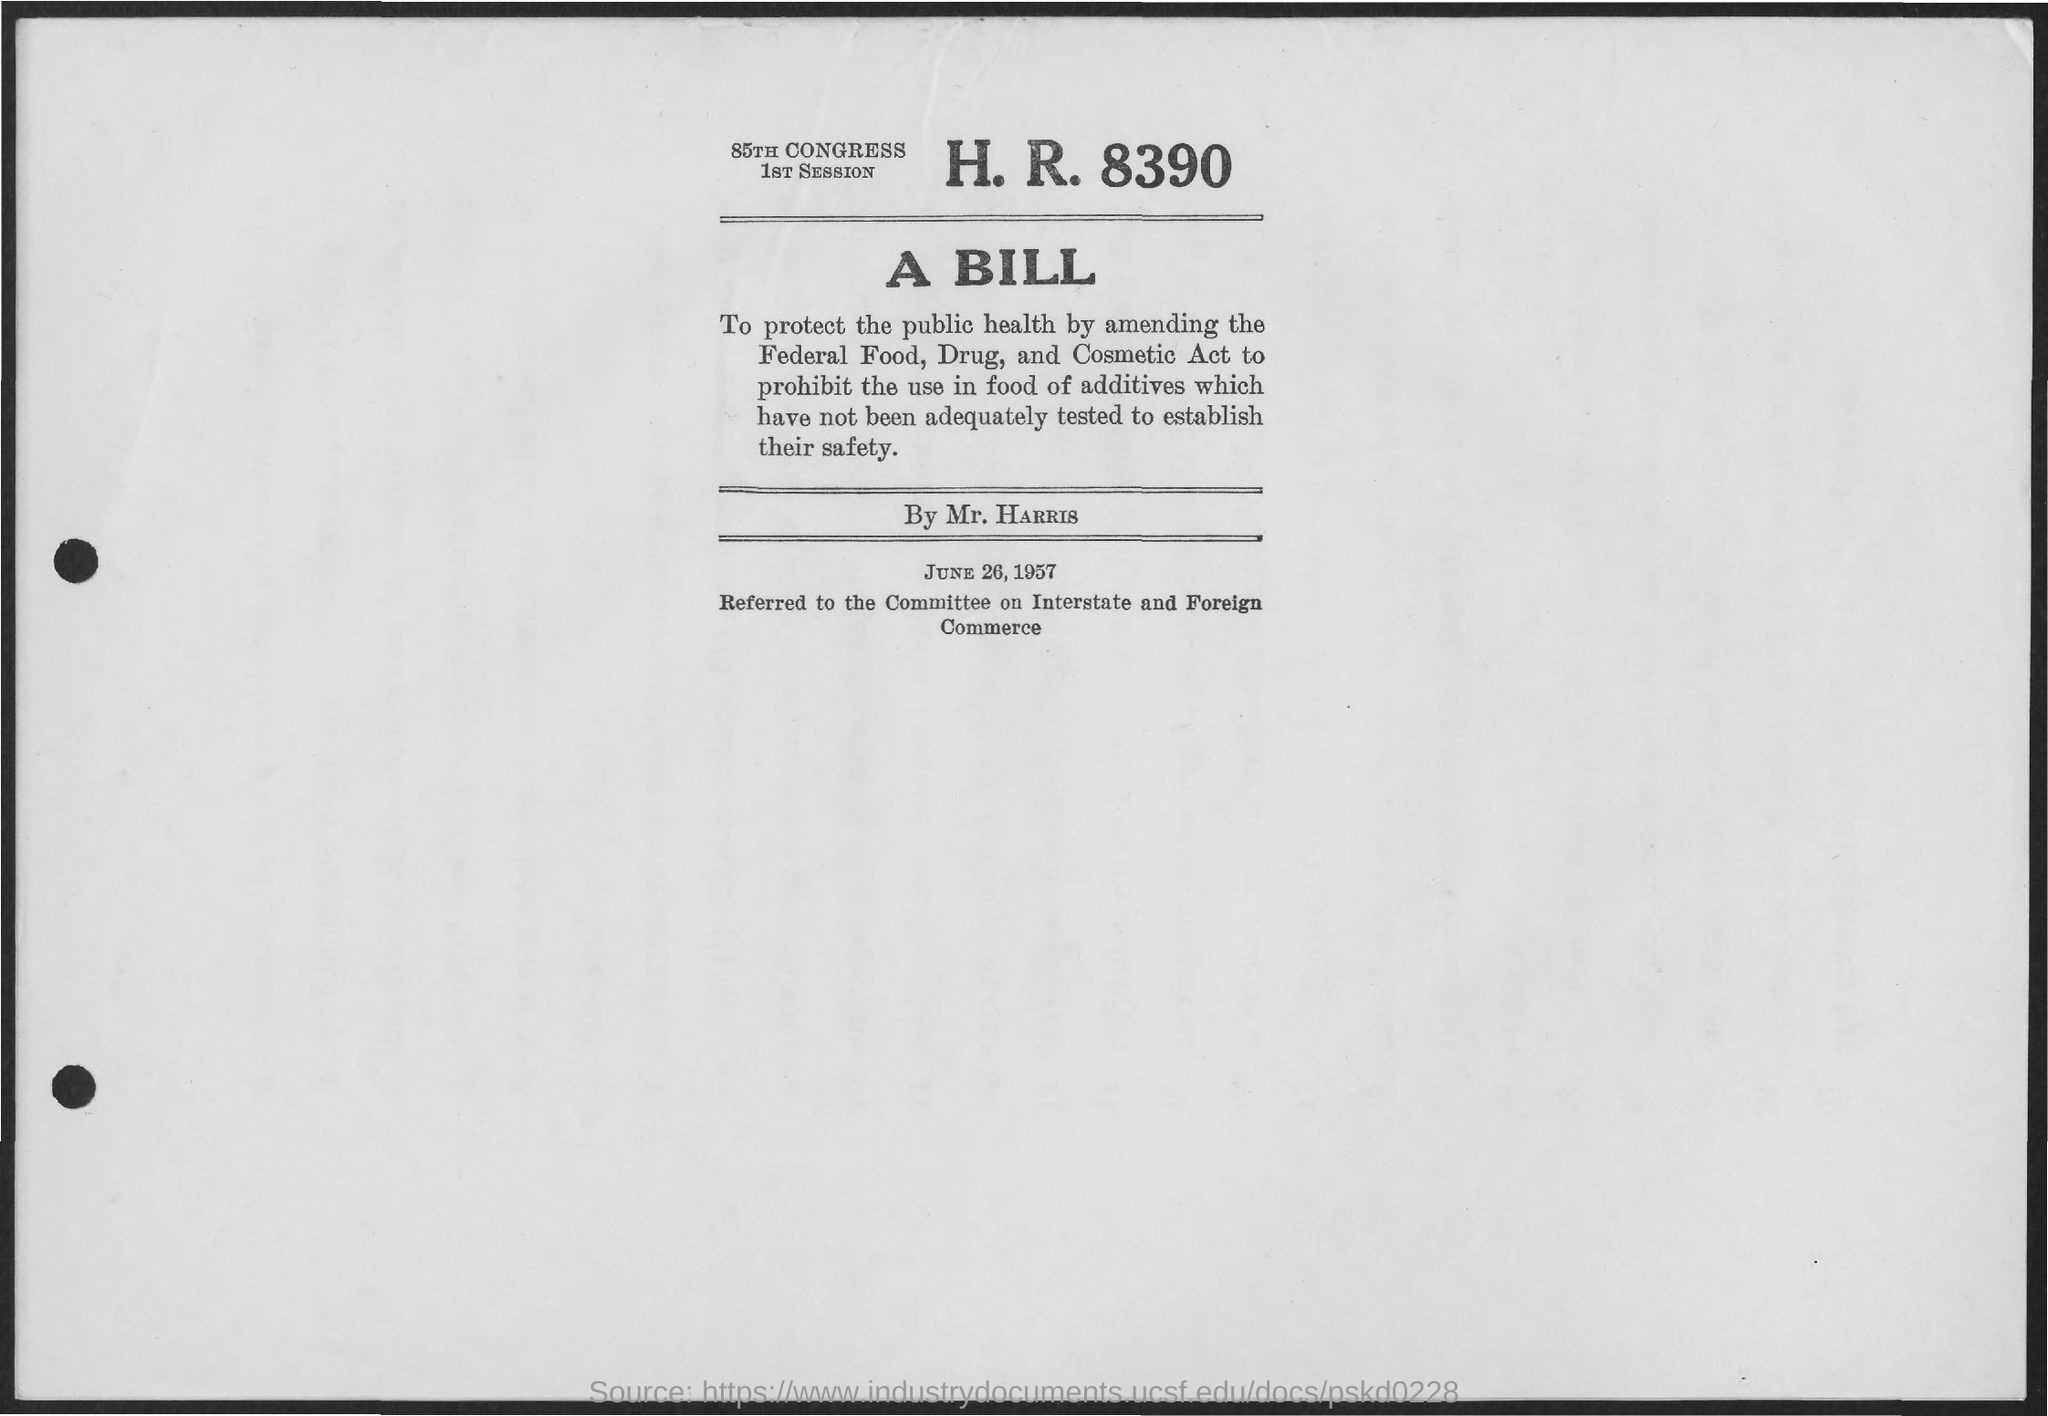List a handful of essential elements in this visual. The date mentioned in the page is June 26, 1957. A bill has been proposed on this page by Mr. Harris. H.R. number 8390 refers to a specific bill or legislation currently pending before the House of Representatives. The bill was introduced in the 85th Congress during the first session. 